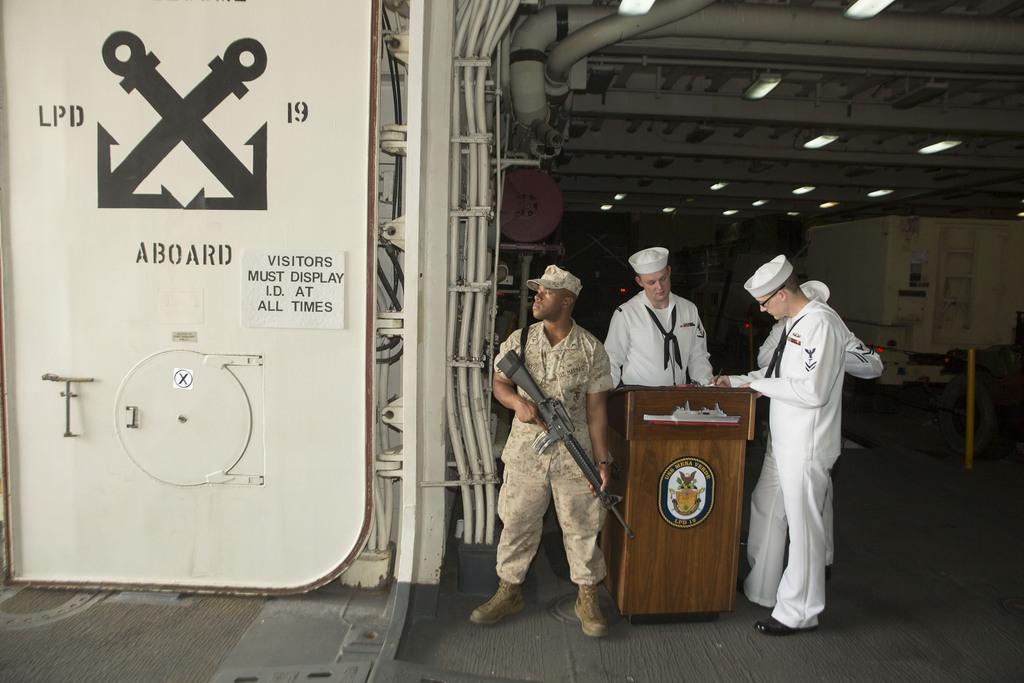In one or two sentences, can you explain what this image depicts? In this picture we can see the people standing. We can see podium, objects and lights. On the left side of the picture we can see a man is standing wearing a cap and he is holding a gun. We can see a board with some information. We can see the text on a whiteboard. 